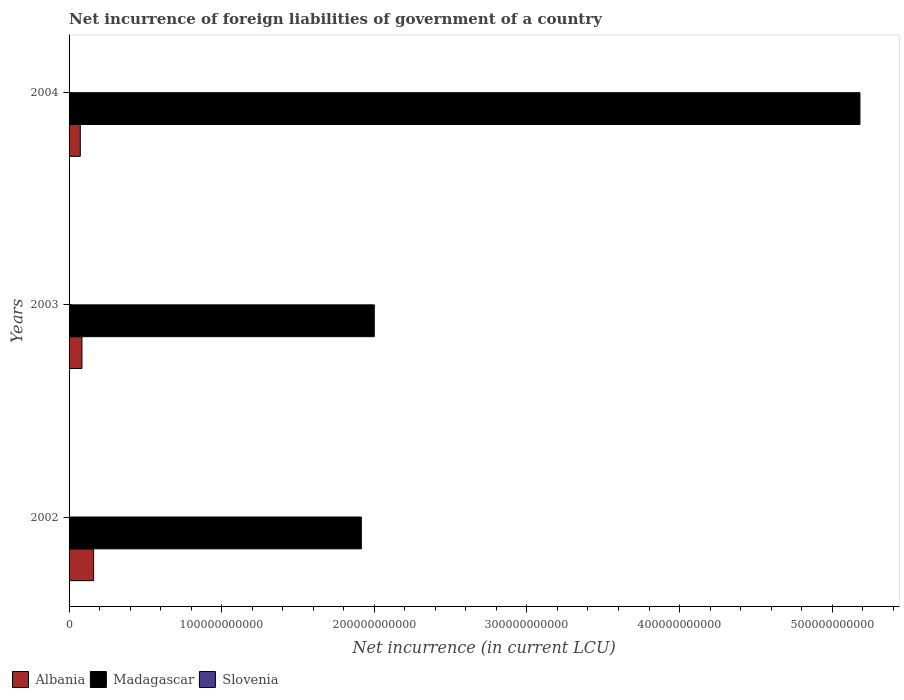How many different coloured bars are there?
Provide a short and direct response. 2. Are the number of bars per tick equal to the number of legend labels?
Ensure brevity in your answer.  No. How many bars are there on the 2nd tick from the top?
Your answer should be compact. 2. What is the label of the 1st group of bars from the top?
Offer a very short reply. 2004. In how many cases, is the number of bars for a given year not equal to the number of legend labels?
Offer a very short reply. 3. What is the net incurrence of foreign liabilities in Albania in 2004?
Offer a very short reply. 7.35e+09. Across all years, what is the maximum net incurrence of foreign liabilities in Albania?
Give a very brief answer. 1.61e+1. Across all years, what is the minimum net incurrence of foreign liabilities in Madagascar?
Offer a very short reply. 1.92e+11. What is the total net incurrence of foreign liabilities in Albania in the graph?
Make the answer very short. 3.19e+1. What is the difference between the net incurrence of foreign liabilities in Madagascar in 2003 and that in 2004?
Ensure brevity in your answer.  -3.18e+11. What is the difference between the net incurrence of foreign liabilities in Albania in 2004 and the net incurrence of foreign liabilities in Madagascar in 2002?
Ensure brevity in your answer.  -1.84e+11. What is the average net incurrence of foreign liabilities in Madagascar per year?
Your response must be concise. 3.03e+11. In the year 2002, what is the difference between the net incurrence of foreign liabilities in Madagascar and net incurrence of foreign liabilities in Albania?
Offer a very short reply. 1.75e+11. In how many years, is the net incurrence of foreign liabilities in Slovenia greater than 140000000000 LCU?
Give a very brief answer. 0. What is the ratio of the net incurrence of foreign liabilities in Madagascar in 2002 to that in 2004?
Keep it short and to the point. 0.37. What is the difference between the highest and the second highest net incurrence of foreign liabilities in Madagascar?
Give a very brief answer. 3.18e+11. What is the difference between the highest and the lowest net incurrence of foreign liabilities in Madagascar?
Make the answer very short. 3.27e+11. Is the sum of the net incurrence of foreign liabilities in Albania in 2003 and 2004 greater than the maximum net incurrence of foreign liabilities in Slovenia across all years?
Provide a succinct answer. Yes. Is it the case that in every year, the sum of the net incurrence of foreign liabilities in Slovenia and net incurrence of foreign liabilities in Madagascar is greater than the net incurrence of foreign liabilities in Albania?
Provide a short and direct response. Yes. Are all the bars in the graph horizontal?
Your response must be concise. Yes. How many years are there in the graph?
Make the answer very short. 3. What is the difference between two consecutive major ticks on the X-axis?
Keep it short and to the point. 1.00e+11. Are the values on the major ticks of X-axis written in scientific E-notation?
Keep it short and to the point. No. Where does the legend appear in the graph?
Your answer should be very brief. Bottom left. How many legend labels are there?
Provide a succinct answer. 3. How are the legend labels stacked?
Provide a succinct answer. Horizontal. What is the title of the graph?
Your response must be concise. Net incurrence of foreign liabilities of government of a country. Does "Haiti" appear as one of the legend labels in the graph?
Keep it short and to the point. No. What is the label or title of the X-axis?
Ensure brevity in your answer.  Net incurrence (in current LCU). What is the label or title of the Y-axis?
Ensure brevity in your answer.  Years. What is the Net incurrence (in current LCU) of Albania in 2002?
Keep it short and to the point. 1.61e+1. What is the Net incurrence (in current LCU) in Madagascar in 2002?
Keep it short and to the point. 1.92e+11. What is the Net incurrence (in current LCU) of Slovenia in 2002?
Offer a terse response. 0. What is the Net incurrence (in current LCU) of Albania in 2003?
Your answer should be compact. 8.44e+09. What is the Net incurrence (in current LCU) of Madagascar in 2003?
Your response must be concise. 2.00e+11. What is the Net incurrence (in current LCU) in Slovenia in 2003?
Give a very brief answer. 0. What is the Net incurrence (in current LCU) of Albania in 2004?
Give a very brief answer. 7.35e+09. What is the Net incurrence (in current LCU) in Madagascar in 2004?
Keep it short and to the point. 5.18e+11. What is the Net incurrence (in current LCU) in Slovenia in 2004?
Offer a terse response. 0. Across all years, what is the maximum Net incurrence (in current LCU) in Albania?
Provide a short and direct response. 1.61e+1. Across all years, what is the maximum Net incurrence (in current LCU) in Madagascar?
Provide a short and direct response. 5.18e+11. Across all years, what is the minimum Net incurrence (in current LCU) in Albania?
Ensure brevity in your answer.  7.35e+09. Across all years, what is the minimum Net incurrence (in current LCU) of Madagascar?
Provide a succinct answer. 1.92e+11. What is the total Net incurrence (in current LCU) in Albania in the graph?
Offer a very short reply. 3.19e+1. What is the total Net incurrence (in current LCU) in Madagascar in the graph?
Keep it short and to the point. 9.10e+11. What is the total Net incurrence (in current LCU) in Slovenia in the graph?
Keep it short and to the point. 0. What is the difference between the Net incurrence (in current LCU) in Albania in 2002 and that in 2003?
Provide a short and direct response. 7.65e+09. What is the difference between the Net incurrence (in current LCU) in Madagascar in 2002 and that in 2003?
Your answer should be very brief. -8.48e+09. What is the difference between the Net incurrence (in current LCU) in Albania in 2002 and that in 2004?
Your answer should be compact. 8.74e+09. What is the difference between the Net incurrence (in current LCU) of Madagascar in 2002 and that in 2004?
Offer a very short reply. -3.27e+11. What is the difference between the Net incurrence (in current LCU) in Albania in 2003 and that in 2004?
Provide a succinct answer. 1.09e+09. What is the difference between the Net incurrence (in current LCU) of Madagascar in 2003 and that in 2004?
Make the answer very short. -3.18e+11. What is the difference between the Net incurrence (in current LCU) in Albania in 2002 and the Net incurrence (in current LCU) in Madagascar in 2003?
Your answer should be compact. -1.84e+11. What is the difference between the Net incurrence (in current LCU) of Albania in 2002 and the Net incurrence (in current LCU) of Madagascar in 2004?
Provide a succinct answer. -5.02e+11. What is the difference between the Net incurrence (in current LCU) in Albania in 2003 and the Net incurrence (in current LCU) in Madagascar in 2004?
Keep it short and to the point. -5.10e+11. What is the average Net incurrence (in current LCU) of Albania per year?
Make the answer very short. 1.06e+1. What is the average Net incurrence (in current LCU) of Madagascar per year?
Make the answer very short. 3.03e+11. In the year 2002, what is the difference between the Net incurrence (in current LCU) of Albania and Net incurrence (in current LCU) of Madagascar?
Your response must be concise. -1.75e+11. In the year 2003, what is the difference between the Net incurrence (in current LCU) in Albania and Net incurrence (in current LCU) in Madagascar?
Offer a terse response. -1.92e+11. In the year 2004, what is the difference between the Net incurrence (in current LCU) in Albania and Net incurrence (in current LCU) in Madagascar?
Offer a terse response. -5.11e+11. What is the ratio of the Net incurrence (in current LCU) in Albania in 2002 to that in 2003?
Provide a short and direct response. 1.91. What is the ratio of the Net incurrence (in current LCU) of Madagascar in 2002 to that in 2003?
Offer a very short reply. 0.96. What is the ratio of the Net incurrence (in current LCU) of Albania in 2002 to that in 2004?
Make the answer very short. 2.19. What is the ratio of the Net incurrence (in current LCU) in Madagascar in 2002 to that in 2004?
Provide a succinct answer. 0.37. What is the ratio of the Net incurrence (in current LCU) of Albania in 2003 to that in 2004?
Ensure brevity in your answer.  1.15. What is the ratio of the Net incurrence (in current LCU) of Madagascar in 2003 to that in 2004?
Ensure brevity in your answer.  0.39. What is the difference between the highest and the second highest Net incurrence (in current LCU) of Albania?
Offer a very short reply. 7.65e+09. What is the difference between the highest and the second highest Net incurrence (in current LCU) of Madagascar?
Provide a succinct answer. 3.18e+11. What is the difference between the highest and the lowest Net incurrence (in current LCU) of Albania?
Your response must be concise. 8.74e+09. What is the difference between the highest and the lowest Net incurrence (in current LCU) in Madagascar?
Keep it short and to the point. 3.27e+11. 